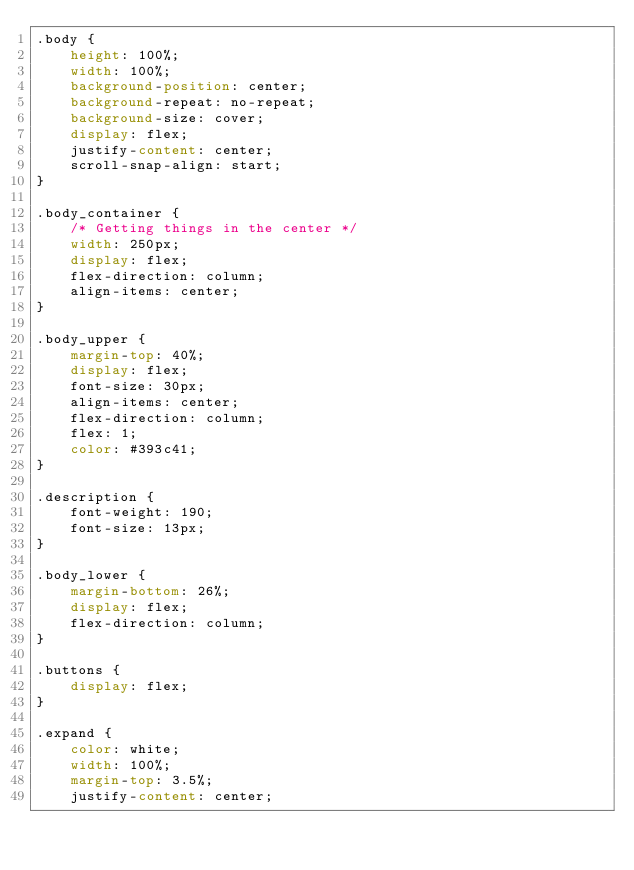Convert code to text. <code><loc_0><loc_0><loc_500><loc_500><_CSS_>.body {
	height: 100%;
	width: 100%;
	background-position: center;
	background-repeat: no-repeat;
	background-size: cover;
	display: flex;
	justify-content: center; 
	scroll-snap-align: start;
}

.body_container {
	/* Getting things in the center */
	width: 250px;
	display: flex;
	flex-direction: column;
	align-items: center;
}

.body_upper {
	margin-top: 40%;
	display: flex;
	font-size: 30px;
	align-items: center;
	flex-direction: column;
	flex: 1;
	color: #393c41;
}

.description {
	font-weight: 190;
	font-size: 13px;
}

.body_lower {
	margin-bottom: 26%;
	display: flex;
	flex-direction: column;
}

.buttons {
	display: flex;
}

.expand {
	color: white;
	width: 100%;
	margin-top: 3.5%;
	justify-content: center;</code> 